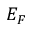Convert formula to latex. <formula><loc_0><loc_0><loc_500><loc_500>E _ { F }</formula> 